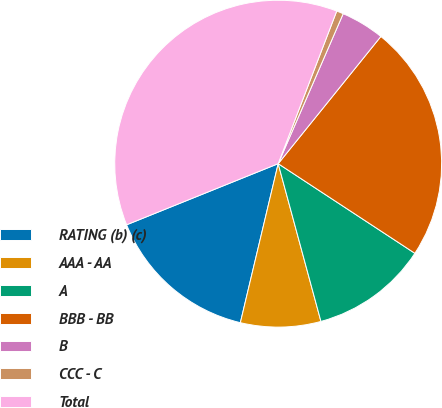Convert chart. <chart><loc_0><loc_0><loc_500><loc_500><pie_chart><fcel>RATING (b) (c)<fcel>AAA - AA<fcel>A<fcel>BBB - BB<fcel>B<fcel>CCC - C<fcel>Total<nl><fcel>15.18%<fcel>7.93%<fcel>11.55%<fcel>23.43%<fcel>4.3%<fcel>0.68%<fcel>36.93%<nl></chart> 